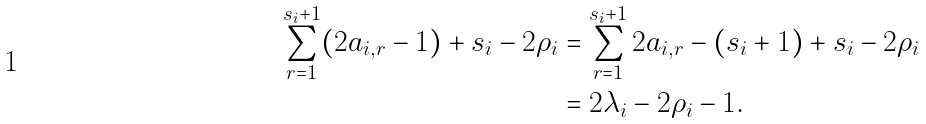<formula> <loc_0><loc_0><loc_500><loc_500>\sum ^ { s _ { i } + 1 } _ { r = 1 } ( 2 a _ { i , r } - 1 ) + s _ { i } - 2 \rho _ { i } & = \sum ^ { s _ { i } + 1 } _ { r = 1 } 2 a _ { i , r } - ( s _ { i } + 1 ) + s _ { i } - 2 \rho _ { i } \\ & = 2 \lambda _ { i } - 2 \rho _ { i } - 1 .</formula> 